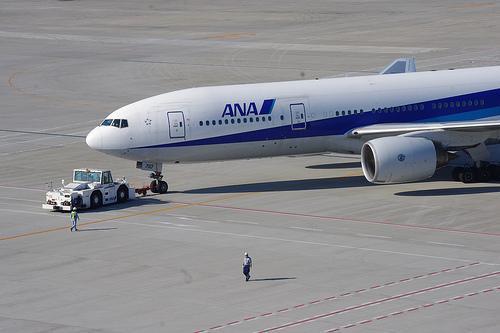How many people are there?
Give a very brief answer. 2. 